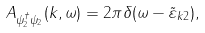<formula> <loc_0><loc_0><loc_500><loc_500>A _ { \psi _ { 2 } ^ { \dagger } \psi _ { 2 } } ( k , \omega ) = 2 \pi \delta ( \omega - \tilde { \varepsilon } _ { k 2 } ) ,</formula> 